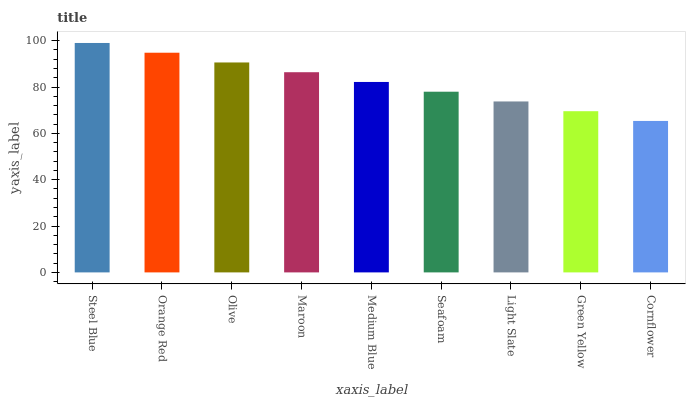Is Cornflower the minimum?
Answer yes or no. Yes. Is Steel Blue the maximum?
Answer yes or no. Yes. Is Orange Red the minimum?
Answer yes or no. No. Is Orange Red the maximum?
Answer yes or no. No. Is Steel Blue greater than Orange Red?
Answer yes or no. Yes. Is Orange Red less than Steel Blue?
Answer yes or no. Yes. Is Orange Red greater than Steel Blue?
Answer yes or no. No. Is Steel Blue less than Orange Red?
Answer yes or no. No. Is Medium Blue the high median?
Answer yes or no. Yes. Is Medium Blue the low median?
Answer yes or no. Yes. Is Olive the high median?
Answer yes or no. No. Is Olive the low median?
Answer yes or no. No. 